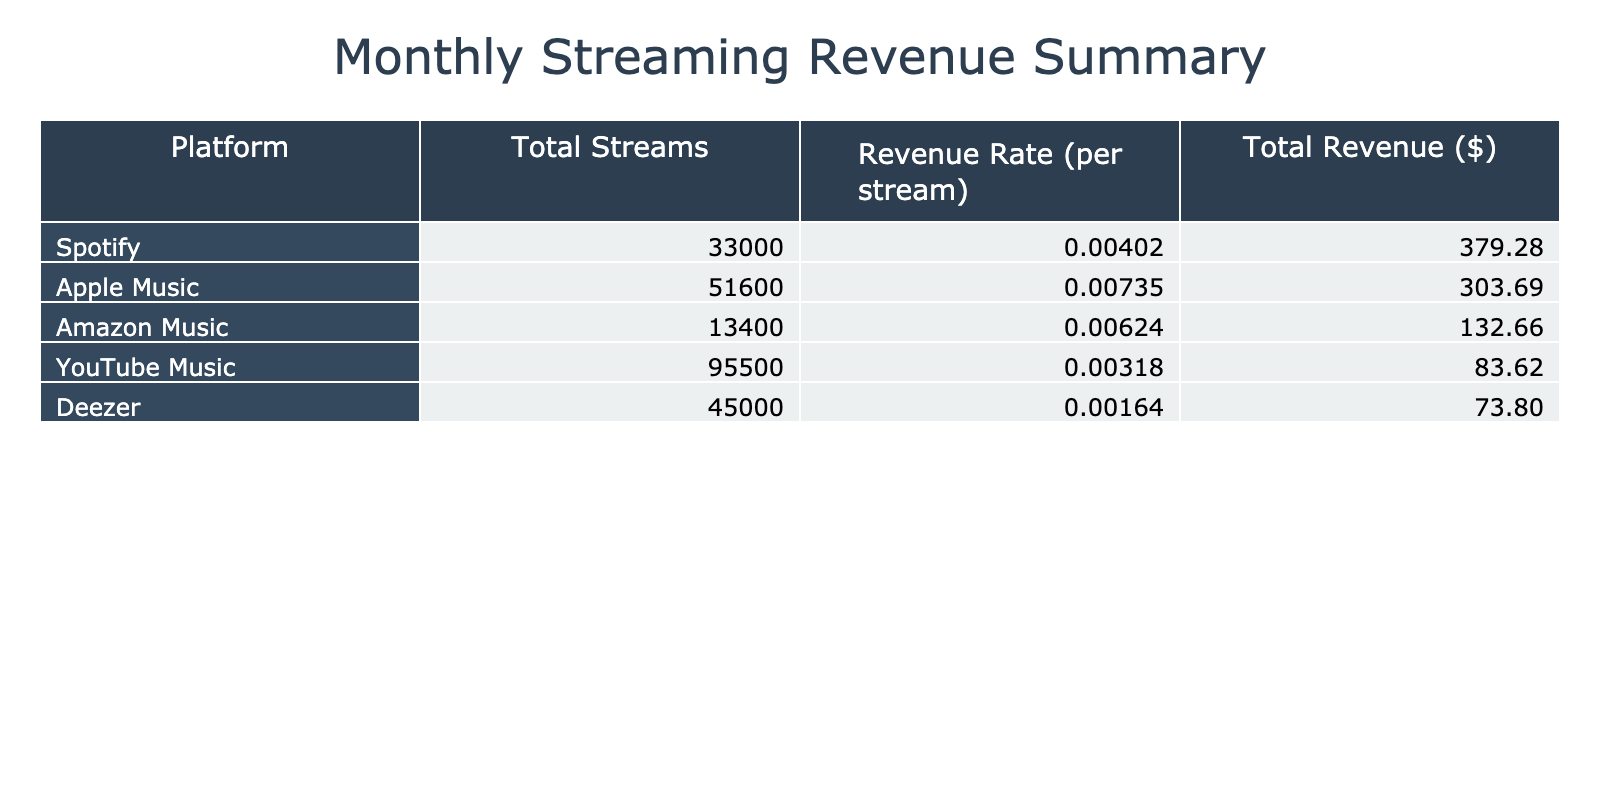What platform generated the highest total revenue? To find the platform with the highest total revenue, we look at the 'Total Revenue ($)' column. The platform with the highest value is Spotify, with a total revenue of 287.95 over the months considered.
Answer: Spotify What was the total number of streams for Apple Music? To calculate the total streams for Apple Music, we sum the streams from all months: 8000 + 9000 + 8500 + 9500 + 7900 + 8700 = 51,600.
Answer: 51600 Is the revenue rate for YouTube Music higher than that for Amazon Music? We compare the revenue rates from the table. YouTube Music has a revenue rate of 0.00164 per stream, while Amazon Music has a revenue rate of 0.00402 per stream. Since 0.00164 is less than 0.00402, the statement is false.
Answer: No What is the average revenue per stream for Deezer over the months? First, we note the revenue rates: January – 0.00624, February – 0.00624, March – 0.00624, April – 0.00624, May – 0.00624, June – 0.00624. Since the rate is constant, we take that as the average, which is 0.00624.
Answer: 0.00624 Which month saw the highest revenue for Amazon Music? We examine the revenue values for Amazon Music: January – 20.10, February – 24.12, March – 22.11, April – 26.13, May – 19.30, June – 20.90. The highest revenue value is from April at 26.13.
Answer: April What is the total revenue generated from all platforms in February? We sum the total revenue for each platform in February: Spotify – 54.06, Apple Music – 66.15, Amazon Music – 24.12, YouTube Music – 13.12, Deezer – 15.60. Adding these gives: 54.06 + 66.15 + 24.12 + 13.12 + 15.60 = 173.05.
Answer: 173.05 Did any platform have lower total streams than Amazon Music? Looking at the total streams for Amazon Music, which is 30,600, we compare this with other platforms: Spotify – 88,500, Apple Music – 51,600, YouTube Music – 41,800, Deezer – 16,200. Deezer is the only platform with streams lower than Amazon Music.
Answer: Yes What was the difference in total revenue between Spotify and Apple Music? The total revenue for Spotify is 287.95, and for Apple Music, it is 285.99. The difference is calculated as 287.95 - 285.99 = 1.96.
Answer: 1.96 